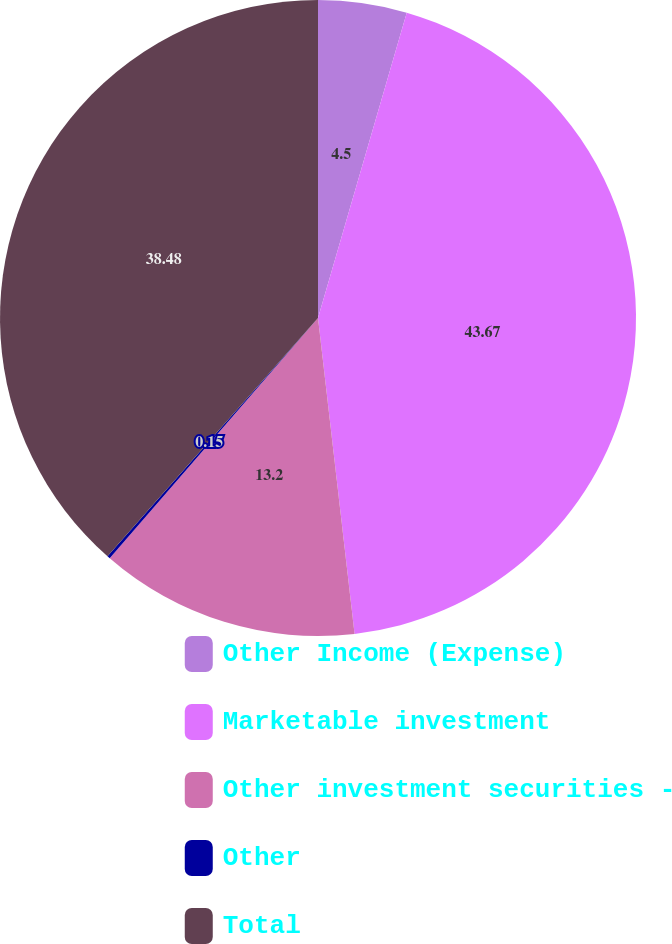<chart> <loc_0><loc_0><loc_500><loc_500><pie_chart><fcel>Other Income (Expense)<fcel>Marketable investment<fcel>Other investment securities -<fcel>Other<fcel>Total<nl><fcel>4.5%<fcel>43.66%<fcel>13.2%<fcel>0.15%<fcel>38.48%<nl></chart> 